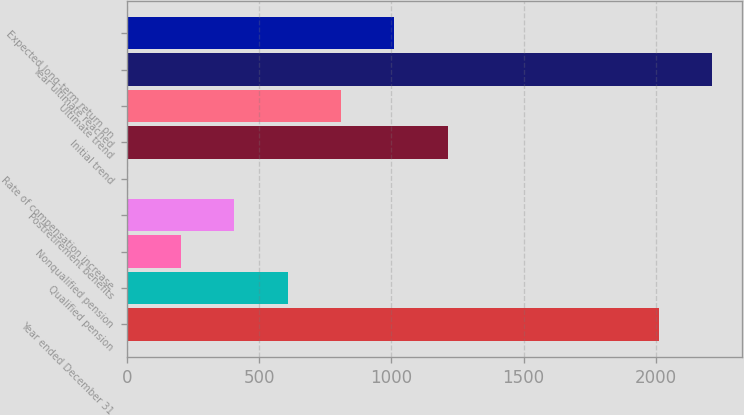Convert chart to OTSL. <chart><loc_0><loc_0><loc_500><loc_500><bar_chart><fcel>Year ended December 31<fcel>Qualified pension<fcel>Nonqualified pension<fcel>Postretirement benefits<fcel>Rate of compensation increase<fcel>Initial trend<fcel>Ultimate trend<fcel>Year ultimate reached<fcel>Expected long-term return on<nl><fcel>2012<fcel>608.5<fcel>205.5<fcel>407<fcel>4<fcel>1213<fcel>810<fcel>2213.5<fcel>1011.5<nl></chart> 